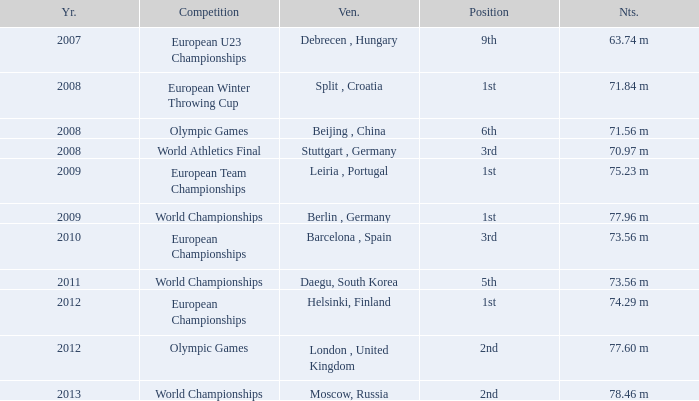What were the notes in 2011? 73.56 m. 